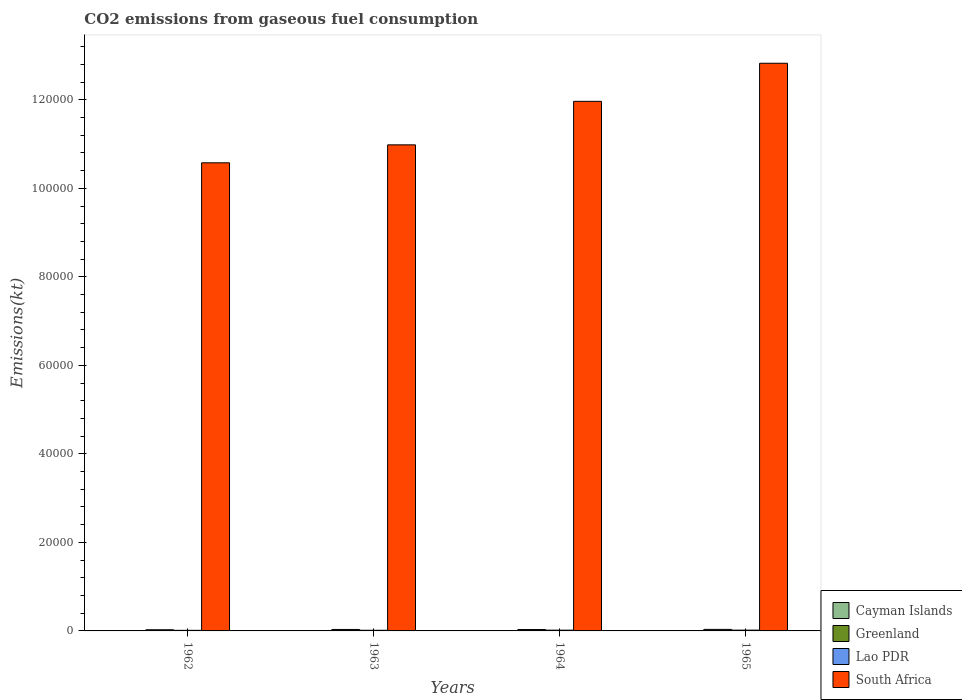How many different coloured bars are there?
Ensure brevity in your answer.  4. Are the number of bars per tick equal to the number of legend labels?
Offer a very short reply. Yes. Are the number of bars on each tick of the X-axis equal?
Provide a short and direct response. Yes. What is the label of the 4th group of bars from the left?
Your answer should be very brief. 1965. In how many cases, is the number of bars for a given year not equal to the number of legend labels?
Provide a succinct answer. 0. What is the amount of CO2 emitted in Lao PDR in 1963?
Your answer should be very brief. 146.68. Across all years, what is the maximum amount of CO2 emitted in Cayman Islands?
Your response must be concise. 11. Across all years, what is the minimum amount of CO2 emitted in Cayman Islands?
Your answer should be very brief. 11. In which year was the amount of CO2 emitted in South Africa maximum?
Offer a terse response. 1965. What is the total amount of CO2 emitted in Lao PDR in the graph?
Offer a terse response. 630.72. What is the difference between the amount of CO2 emitted in Greenland in 1963 and that in 1965?
Offer a very short reply. -14.67. What is the difference between the amount of CO2 emitted in Lao PDR in 1963 and the amount of CO2 emitted in Cayman Islands in 1964?
Your answer should be compact. 135.68. What is the average amount of CO2 emitted in South Africa per year?
Provide a short and direct response. 1.16e+05. In the year 1962, what is the difference between the amount of CO2 emitted in Cayman Islands and amount of CO2 emitted in Greenland?
Ensure brevity in your answer.  -253.02. In how many years, is the amount of CO2 emitted in South Africa greater than 44000 kt?
Make the answer very short. 4. What is the ratio of the amount of CO2 emitted in Lao PDR in 1962 to that in 1965?
Offer a terse response. 0.73. Is the amount of CO2 emitted in Cayman Islands in 1964 less than that in 1965?
Ensure brevity in your answer.  No. Is the difference between the amount of CO2 emitted in Cayman Islands in 1962 and 1965 greater than the difference between the amount of CO2 emitted in Greenland in 1962 and 1965?
Your answer should be very brief. Yes. What is the difference between the highest and the second highest amount of CO2 emitted in Lao PDR?
Provide a succinct answer. 7.33. What is the difference between the highest and the lowest amount of CO2 emitted in South Africa?
Offer a terse response. 2.25e+04. What does the 4th bar from the left in 1963 represents?
Your answer should be compact. South Africa. What does the 1st bar from the right in 1963 represents?
Offer a terse response. South Africa. How many years are there in the graph?
Your response must be concise. 4. What is the difference between two consecutive major ticks on the Y-axis?
Give a very brief answer. 2.00e+04. Does the graph contain any zero values?
Ensure brevity in your answer.  No. Does the graph contain grids?
Your answer should be compact. No. Where does the legend appear in the graph?
Your answer should be very brief. Bottom right. How are the legend labels stacked?
Keep it short and to the point. Vertical. What is the title of the graph?
Provide a succinct answer. CO2 emissions from gaseous fuel consumption. What is the label or title of the X-axis?
Your response must be concise. Years. What is the label or title of the Y-axis?
Offer a terse response. Emissions(kt). What is the Emissions(kt) in Cayman Islands in 1962?
Offer a terse response. 11. What is the Emissions(kt) of Greenland in 1962?
Offer a very short reply. 264.02. What is the Emissions(kt) of Lao PDR in 1962?
Your response must be concise. 132.01. What is the Emissions(kt) in South Africa in 1962?
Offer a very short reply. 1.06e+05. What is the Emissions(kt) of Cayman Islands in 1963?
Your response must be concise. 11. What is the Emissions(kt) of Greenland in 1963?
Give a very brief answer. 330.03. What is the Emissions(kt) in Lao PDR in 1963?
Your response must be concise. 146.68. What is the Emissions(kt) of South Africa in 1963?
Your response must be concise. 1.10e+05. What is the Emissions(kt) of Cayman Islands in 1964?
Offer a terse response. 11. What is the Emissions(kt) in Greenland in 1964?
Provide a succinct answer. 315.36. What is the Emissions(kt) of Lao PDR in 1964?
Ensure brevity in your answer.  172.35. What is the Emissions(kt) in South Africa in 1964?
Your response must be concise. 1.20e+05. What is the Emissions(kt) of Cayman Islands in 1965?
Your answer should be compact. 11. What is the Emissions(kt) in Greenland in 1965?
Your response must be concise. 344.7. What is the Emissions(kt) of Lao PDR in 1965?
Keep it short and to the point. 179.68. What is the Emissions(kt) of South Africa in 1965?
Offer a terse response. 1.28e+05. Across all years, what is the maximum Emissions(kt) of Cayman Islands?
Keep it short and to the point. 11. Across all years, what is the maximum Emissions(kt) of Greenland?
Offer a terse response. 344.7. Across all years, what is the maximum Emissions(kt) of Lao PDR?
Ensure brevity in your answer.  179.68. Across all years, what is the maximum Emissions(kt) of South Africa?
Offer a very short reply. 1.28e+05. Across all years, what is the minimum Emissions(kt) of Cayman Islands?
Offer a very short reply. 11. Across all years, what is the minimum Emissions(kt) in Greenland?
Keep it short and to the point. 264.02. Across all years, what is the minimum Emissions(kt) of Lao PDR?
Provide a short and direct response. 132.01. Across all years, what is the minimum Emissions(kt) in South Africa?
Ensure brevity in your answer.  1.06e+05. What is the total Emissions(kt) in Cayman Islands in the graph?
Your answer should be very brief. 44. What is the total Emissions(kt) of Greenland in the graph?
Make the answer very short. 1254.11. What is the total Emissions(kt) in Lao PDR in the graph?
Your answer should be compact. 630.72. What is the total Emissions(kt) in South Africa in the graph?
Keep it short and to the point. 4.64e+05. What is the difference between the Emissions(kt) of Greenland in 1962 and that in 1963?
Give a very brief answer. -66.01. What is the difference between the Emissions(kt) of Lao PDR in 1962 and that in 1963?
Your response must be concise. -14.67. What is the difference between the Emissions(kt) of South Africa in 1962 and that in 1963?
Ensure brevity in your answer.  -4059.37. What is the difference between the Emissions(kt) of Greenland in 1962 and that in 1964?
Provide a succinct answer. -51.34. What is the difference between the Emissions(kt) in Lao PDR in 1962 and that in 1964?
Provide a short and direct response. -40.34. What is the difference between the Emissions(kt) in South Africa in 1962 and that in 1964?
Make the answer very short. -1.39e+04. What is the difference between the Emissions(kt) in Greenland in 1962 and that in 1965?
Provide a short and direct response. -80.67. What is the difference between the Emissions(kt) in Lao PDR in 1962 and that in 1965?
Give a very brief answer. -47.67. What is the difference between the Emissions(kt) in South Africa in 1962 and that in 1965?
Your response must be concise. -2.25e+04. What is the difference between the Emissions(kt) of Greenland in 1963 and that in 1964?
Give a very brief answer. 14.67. What is the difference between the Emissions(kt) in Lao PDR in 1963 and that in 1964?
Your response must be concise. -25.67. What is the difference between the Emissions(kt) in South Africa in 1963 and that in 1964?
Your answer should be very brief. -9831.23. What is the difference between the Emissions(kt) of Cayman Islands in 1963 and that in 1965?
Provide a short and direct response. 0. What is the difference between the Emissions(kt) in Greenland in 1963 and that in 1965?
Your response must be concise. -14.67. What is the difference between the Emissions(kt) of Lao PDR in 1963 and that in 1965?
Your answer should be compact. -33. What is the difference between the Emissions(kt) of South Africa in 1963 and that in 1965?
Give a very brief answer. -1.84e+04. What is the difference between the Emissions(kt) of Greenland in 1964 and that in 1965?
Your answer should be compact. -29.34. What is the difference between the Emissions(kt) in Lao PDR in 1964 and that in 1965?
Make the answer very short. -7.33. What is the difference between the Emissions(kt) of South Africa in 1964 and that in 1965?
Your answer should be compact. -8602.78. What is the difference between the Emissions(kt) in Cayman Islands in 1962 and the Emissions(kt) in Greenland in 1963?
Provide a short and direct response. -319.03. What is the difference between the Emissions(kt) of Cayman Islands in 1962 and the Emissions(kt) of Lao PDR in 1963?
Make the answer very short. -135.68. What is the difference between the Emissions(kt) in Cayman Islands in 1962 and the Emissions(kt) in South Africa in 1963?
Your response must be concise. -1.10e+05. What is the difference between the Emissions(kt) of Greenland in 1962 and the Emissions(kt) of Lao PDR in 1963?
Make the answer very short. 117.34. What is the difference between the Emissions(kt) in Greenland in 1962 and the Emissions(kt) in South Africa in 1963?
Give a very brief answer. -1.10e+05. What is the difference between the Emissions(kt) of Lao PDR in 1962 and the Emissions(kt) of South Africa in 1963?
Provide a succinct answer. -1.10e+05. What is the difference between the Emissions(kt) in Cayman Islands in 1962 and the Emissions(kt) in Greenland in 1964?
Your answer should be compact. -304.36. What is the difference between the Emissions(kt) in Cayman Islands in 1962 and the Emissions(kt) in Lao PDR in 1964?
Give a very brief answer. -161.35. What is the difference between the Emissions(kt) of Cayman Islands in 1962 and the Emissions(kt) of South Africa in 1964?
Your answer should be very brief. -1.20e+05. What is the difference between the Emissions(kt) in Greenland in 1962 and the Emissions(kt) in Lao PDR in 1964?
Your response must be concise. 91.67. What is the difference between the Emissions(kt) of Greenland in 1962 and the Emissions(kt) of South Africa in 1964?
Offer a terse response. -1.19e+05. What is the difference between the Emissions(kt) of Lao PDR in 1962 and the Emissions(kt) of South Africa in 1964?
Offer a very short reply. -1.20e+05. What is the difference between the Emissions(kt) in Cayman Islands in 1962 and the Emissions(kt) in Greenland in 1965?
Make the answer very short. -333.7. What is the difference between the Emissions(kt) in Cayman Islands in 1962 and the Emissions(kt) in Lao PDR in 1965?
Offer a very short reply. -168.68. What is the difference between the Emissions(kt) in Cayman Islands in 1962 and the Emissions(kt) in South Africa in 1965?
Your answer should be very brief. -1.28e+05. What is the difference between the Emissions(kt) in Greenland in 1962 and the Emissions(kt) in Lao PDR in 1965?
Provide a succinct answer. 84.34. What is the difference between the Emissions(kt) of Greenland in 1962 and the Emissions(kt) of South Africa in 1965?
Your answer should be compact. -1.28e+05. What is the difference between the Emissions(kt) of Lao PDR in 1962 and the Emissions(kt) of South Africa in 1965?
Ensure brevity in your answer.  -1.28e+05. What is the difference between the Emissions(kt) in Cayman Islands in 1963 and the Emissions(kt) in Greenland in 1964?
Provide a short and direct response. -304.36. What is the difference between the Emissions(kt) in Cayman Islands in 1963 and the Emissions(kt) in Lao PDR in 1964?
Your response must be concise. -161.35. What is the difference between the Emissions(kt) of Cayman Islands in 1963 and the Emissions(kt) of South Africa in 1964?
Provide a short and direct response. -1.20e+05. What is the difference between the Emissions(kt) of Greenland in 1963 and the Emissions(kt) of Lao PDR in 1964?
Give a very brief answer. 157.68. What is the difference between the Emissions(kt) in Greenland in 1963 and the Emissions(kt) in South Africa in 1964?
Offer a terse response. -1.19e+05. What is the difference between the Emissions(kt) in Lao PDR in 1963 and the Emissions(kt) in South Africa in 1964?
Ensure brevity in your answer.  -1.20e+05. What is the difference between the Emissions(kt) of Cayman Islands in 1963 and the Emissions(kt) of Greenland in 1965?
Offer a terse response. -333.7. What is the difference between the Emissions(kt) in Cayman Islands in 1963 and the Emissions(kt) in Lao PDR in 1965?
Keep it short and to the point. -168.68. What is the difference between the Emissions(kt) of Cayman Islands in 1963 and the Emissions(kt) of South Africa in 1965?
Your answer should be compact. -1.28e+05. What is the difference between the Emissions(kt) of Greenland in 1963 and the Emissions(kt) of Lao PDR in 1965?
Your response must be concise. 150.35. What is the difference between the Emissions(kt) in Greenland in 1963 and the Emissions(kt) in South Africa in 1965?
Your answer should be very brief. -1.28e+05. What is the difference between the Emissions(kt) of Lao PDR in 1963 and the Emissions(kt) of South Africa in 1965?
Keep it short and to the point. -1.28e+05. What is the difference between the Emissions(kt) in Cayman Islands in 1964 and the Emissions(kt) in Greenland in 1965?
Keep it short and to the point. -333.7. What is the difference between the Emissions(kt) of Cayman Islands in 1964 and the Emissions(kt) of Lao PDR in 1965?
Offer a terse response. -168.68. What is the difference between the Emissions(kt) of Cayman Islands in 1964 and the Emissions(kt) of South Africa in 1965?
Offer a very short reply. -1.28e+05. What is the difference between the Emissions(kt) of Greenland in 1964 and the Emissions(kt) of Lao PDR in 1965?
Keep it short and to the point. 135.68. What is the difference between the Emissions(kt) in Greenland in 1964 and the Emissions(kt) in South Africa in 1965?
Give a very brief answer. -1.28e+05. What is the difference between the Emissions(kt) of Lao PDR in 1964 and the Emissions(kt) of South Africa in 1965?
Ensure brevity in your answer.  -1.28e+05. What is the average Emissions(kt) in Cayman Islands per year?
Your answer should be compact. 11. What is the average Emissions(kt) in Greenland per year?
Offer a terse response. 313.53. What is the average Emissions(kt) of Lao PDR per year?
Your answer should be compact. 157.68. What is the average Emissions(kt) of South Africa per year?
Make the answer very short. 1.16e+05. In the year 1962, what is the difference between the Emissions(kt) in Cayman Islands and Emissions(kt) in Greenland?
Provide a short and direct response. -253.02. In the year 1962, what is the difference between the Emissions(kt) of Cayman Islands and Emissions(kt) of Lao PDR?
Your answer should be very brief. -121.01. In the year 1962, what is the difference between the Emissions(kt) of Cayman Islands and Emissions(kt) of South Africa?
Offer a terse response. -1.06e+05. In the year 1962, what is the difference between the Emissions(kt) of Greenland and Emissions(kt) of Lao PDR?
Make the answer very short. 132.01. In the year 1962, what is the difference between the Emissions(kt) of Greenland and Emissions(kt) of South Africa?
Provide a short and direct response. -1.06e+05. In the year 1962, what is the difference between the Emissions(kt) of Lao PDR and Emissions(kt) of South Africa?
Give a very brief answer. -1.06e+05. In the year 1963, what is the difference between the Emissions(kt) in Cayman Islands and Emissions(kt) in Greenland?
Provide a short and direct response. -319.03. In the year 1963, what is the difference between the Emissions(kt) in Cayman Islands and Emissions(kt) in Lao PDR?
Ensure brevity in your answer.  -135.68. In the year 1963, what is the difference between the Emissions(kt) in Cayman Islands and Emissions(kt) in South Africa?
Provide a succinct answer. -1.10e+05. In the year 1963, what is the difference between the Emissions(kt) of Greenland and Emissions(kt) of Lao PDR?
Provide a short and direct response. 183.35. In the year 1963, what is the difference between the Emissions(kt) of Greenland and Emissions(kt) of South Africa?
Your answer should be compact. -1.09e+05. In the year 1963, what is the difference between the Emissions(kt) in Lao PDR and Emissions(kt) in South Africa?
Your answer should be compact. -1.10e+05. In the year 1964, what is the difference between the Emissions(kt) in Cayman Islands and Emissions(kt) in Greenland?
Provide a succinct answer. -304.36. In the year 1964, what is the difference between the Emissions(kt) in Cayman Islands and Emissions(kt) in Lao PDR?
Keep it short and to the point. -161.35. In the year 1964, what is the difference between the Emissions(kt) of Cayman Islands and Emissions(kt) of South Africa?
Offer a very short reply. -1.20e+05. In the year 1964, what is the difference between the Emissions(kt) in Greenland and Emissions(kt) in Lao PDR?
Give a very brief answer. 143.01. In the year 1964, what is the difference between the Emissions(kt) of Greenland and Emissions(kt) of South Africa?
Make the answer very short. -1.19e+05. In the year 1964, what is the difference between the Emissions(kt) of Lao PDR and Emissions(kt) of South Africa?
Provide a short and direct response. -1.19e+05. In the year 1965, what is the difference between the Emissions(kt) in Cayman Islands and Emissions(kt) in Greenland?
Provide a short and direct response. -333.7. In the year 1965, what is the difference between the Emissions(kt) of Cayman Islands and Emissions(kt) of Lao PDR?
Provide a succinct answer. -168.68. In the year 1965, what is the difference between the Emissions(kt) in Cayman Islands and Emissions(kt) in South Africa?
Provide a short and direct response. -1.28e+05. In the year 1965, what is the difference between the Emissions(kt) of Greenland and Emissions(kt) of Lao PDR?
Your answer should be compact. 165.01. In the year 1965, what is the difference between the Emissions(kt) of Greenland and Emissions(kt) of South Africa?
Provide a succinct answer. -1.28e+05. In the year 1965, what is the difference between the Emissions(kt) of Lao PDR and Emissions(kt) of South Africa?
Offer a terse response. -1.28e+05. What is the ratio of the Emissions(kt) in South Africa in 1962 to that in 1963?
Ensure brevity in your answer.  0.96. What is the ratio of the Emissions(kt) of Cayman Islands in 1962 to that in 1964?
Offer a terse response. 1. What is the ratio of the Emissions(kt) of Greenland in 1962 to that in 1964?
Your answer should be very brief. 0.84. What is the ratio of the Emissions(kt) in Lao PDR in 1962 to that in 1964?
Provide a short and direct response. 0.77. What is the ratio of the Emissions(kt) in South Africa in 1962 to that in 1964?
Your response must be concise. 0.88. What is the ratio of the Emissions(kt) in Greenland in 1962 to that in 1965?
Your answer should be very brief. 0.77. What is the ratio of the Emissions(kt) in Lao PDR in 1962 to that in 1965?
Provide a succinct answer. 0.73. What is the ratio of the Emissions(kt) in South Africa in 1962 to that in 1965?
Your response must be concise. 0.82. What is the ratio of the Emissions(kt) of Greenland in 1963 to that in 1964?
Make the answer very short. 1.05. What is the ratio of the Emissions(kt) in Lao PDR in 1963 to that in 1964?
Give a very brief answer. 0.85. What is the ratio of the Emissions(kt) of South Africa in 1963 to that in 1964?
Offer a very short reply. 0.92. What is the ratio of the Emissions(kt) of Cayman Islands in 1963 to that in 1965?
Your answer should be compact. 1. What is the ratio of the Emissions(kt) in Greenland in 1963 to that in 1965?
Your answer should be very brief. 0.96. What is the ratio of the Emissions(kt) in Lao PDR in 1963 to that in 1965?
Provide a succinct answer. 0.82. What is the ratio of the Emissions(kt) of South Africa in 1963 to that in 1965?
Offer a very short reply. 0.86. What is the ratio of the Emissions(kt) of Greenland in 1964 to that in 1965?
Offer a terse response. 0.91. What is the ratio of the Emissions(kt) in Lao PDR in 1964 to that in 1965?
Your response must be concise. 0.96. What is the ratio of the Emissions(kt) in South Africa in 1964 to that in 1965?
Make the answer very short. 0.93. What is the difference between the highest and the second highest Emissions(kt) of Cayman Islands?
Offer a terse response. 0. What is the difference between the highest and the second highest Emissions(kt) in Greenland?
Offer a very short reply. 14.67. What is the difference between the highest and the second highest Emissions(kt) of Lao PDR?
Your response must be concise. 7.33. What is the difference between the highest and the second highest Emissions(kt) in South Africa?
Your answer should be very brief. 8602.78. What is the difference between the highest and the lowest Emissions(kt) in Greenland?
Give a very brief answer. 80.67. What is the difference between the highest and the lowest Emissions(kt) of Lao PDR?
Your response must be concise. 47.67. What is the difference between the highest and the lowest Emissions(kt) of South Africa?
Your response must be concise. 2.25e+04. 